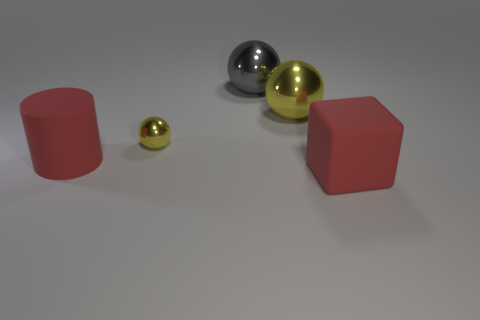Add 3 matte things. How many objects exist? 8 Subtract all cylinders. How many objects are left? 4 Add 2 big cyan metallic spheres. How many big cyan metallic spheres exist? 2 Subtract 0 brown balls. How many objects are left? 5 Subtract all red cylinders. Subtract all large cylinders. How many objects are left? 3 Add 5 big metal balls. How many big metal balls are left? 7 